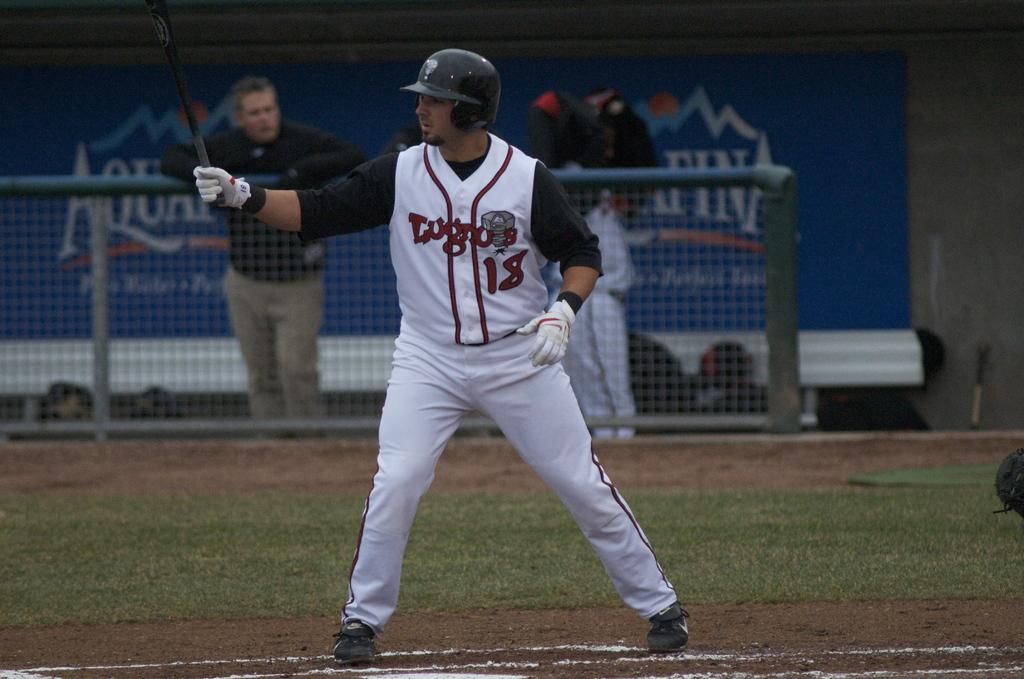<image>
Give a short and clear explanation of the subsequent image. Baseball player wearing number 18 about to bat the ball. 